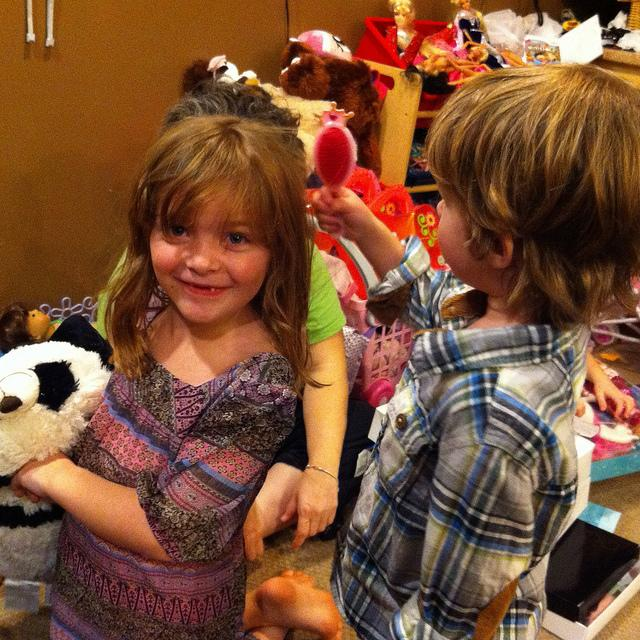What is the design called on the boy's shirt? Please explain your reasoning. flannel. It is checkered and warm looking. 